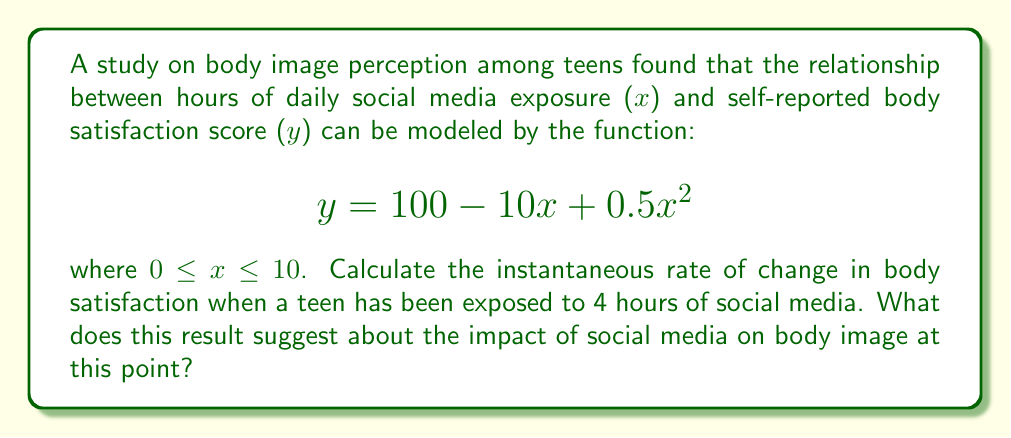What is the answer to this math problem? To find the instantaneous rate of change, we need to calculate the derivative of the given function and evaluate it at $x = 4$.

Step 1: Find the derivative of the function.
$$y = 100 - 10x + 0.5x^2$$
$$\frac{dy}{dx} = -10 + x$$

Step 2: Evaluate the derivative at $x = 4$.
$$\frac{dy}{dx}\bigg|_{x=4} = -10 + 4 = -6$$

Step 3: Interpret the result.
The instantaneous rate of change at 4 hours of social media exposure is -6 points per hour. This negative value indicates that at this point, increased social media exposure is associated with a decrease in body satisfaction.

Step 4: Contextualize the answer.
For a body-positive teen, this result suggests that after 4 hours of social media use, additional exposure is linked to a decline in body satisfaction. This highlights the importance of mindful media consumption and the potential negative impacts of prolonged social media use on body image.
Answer: $-6$ points per hour 